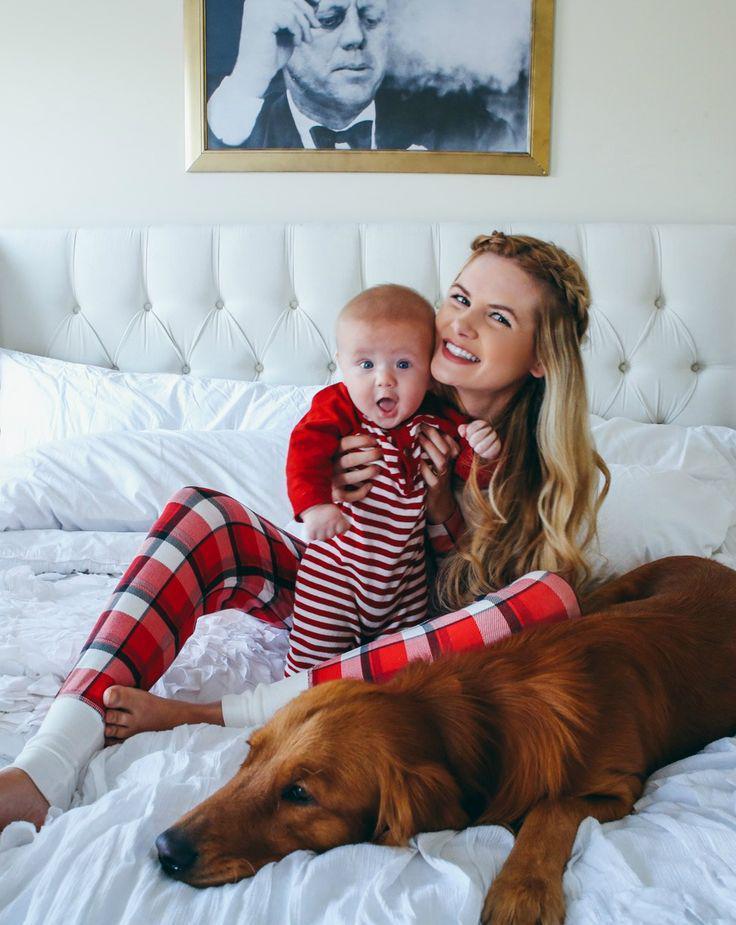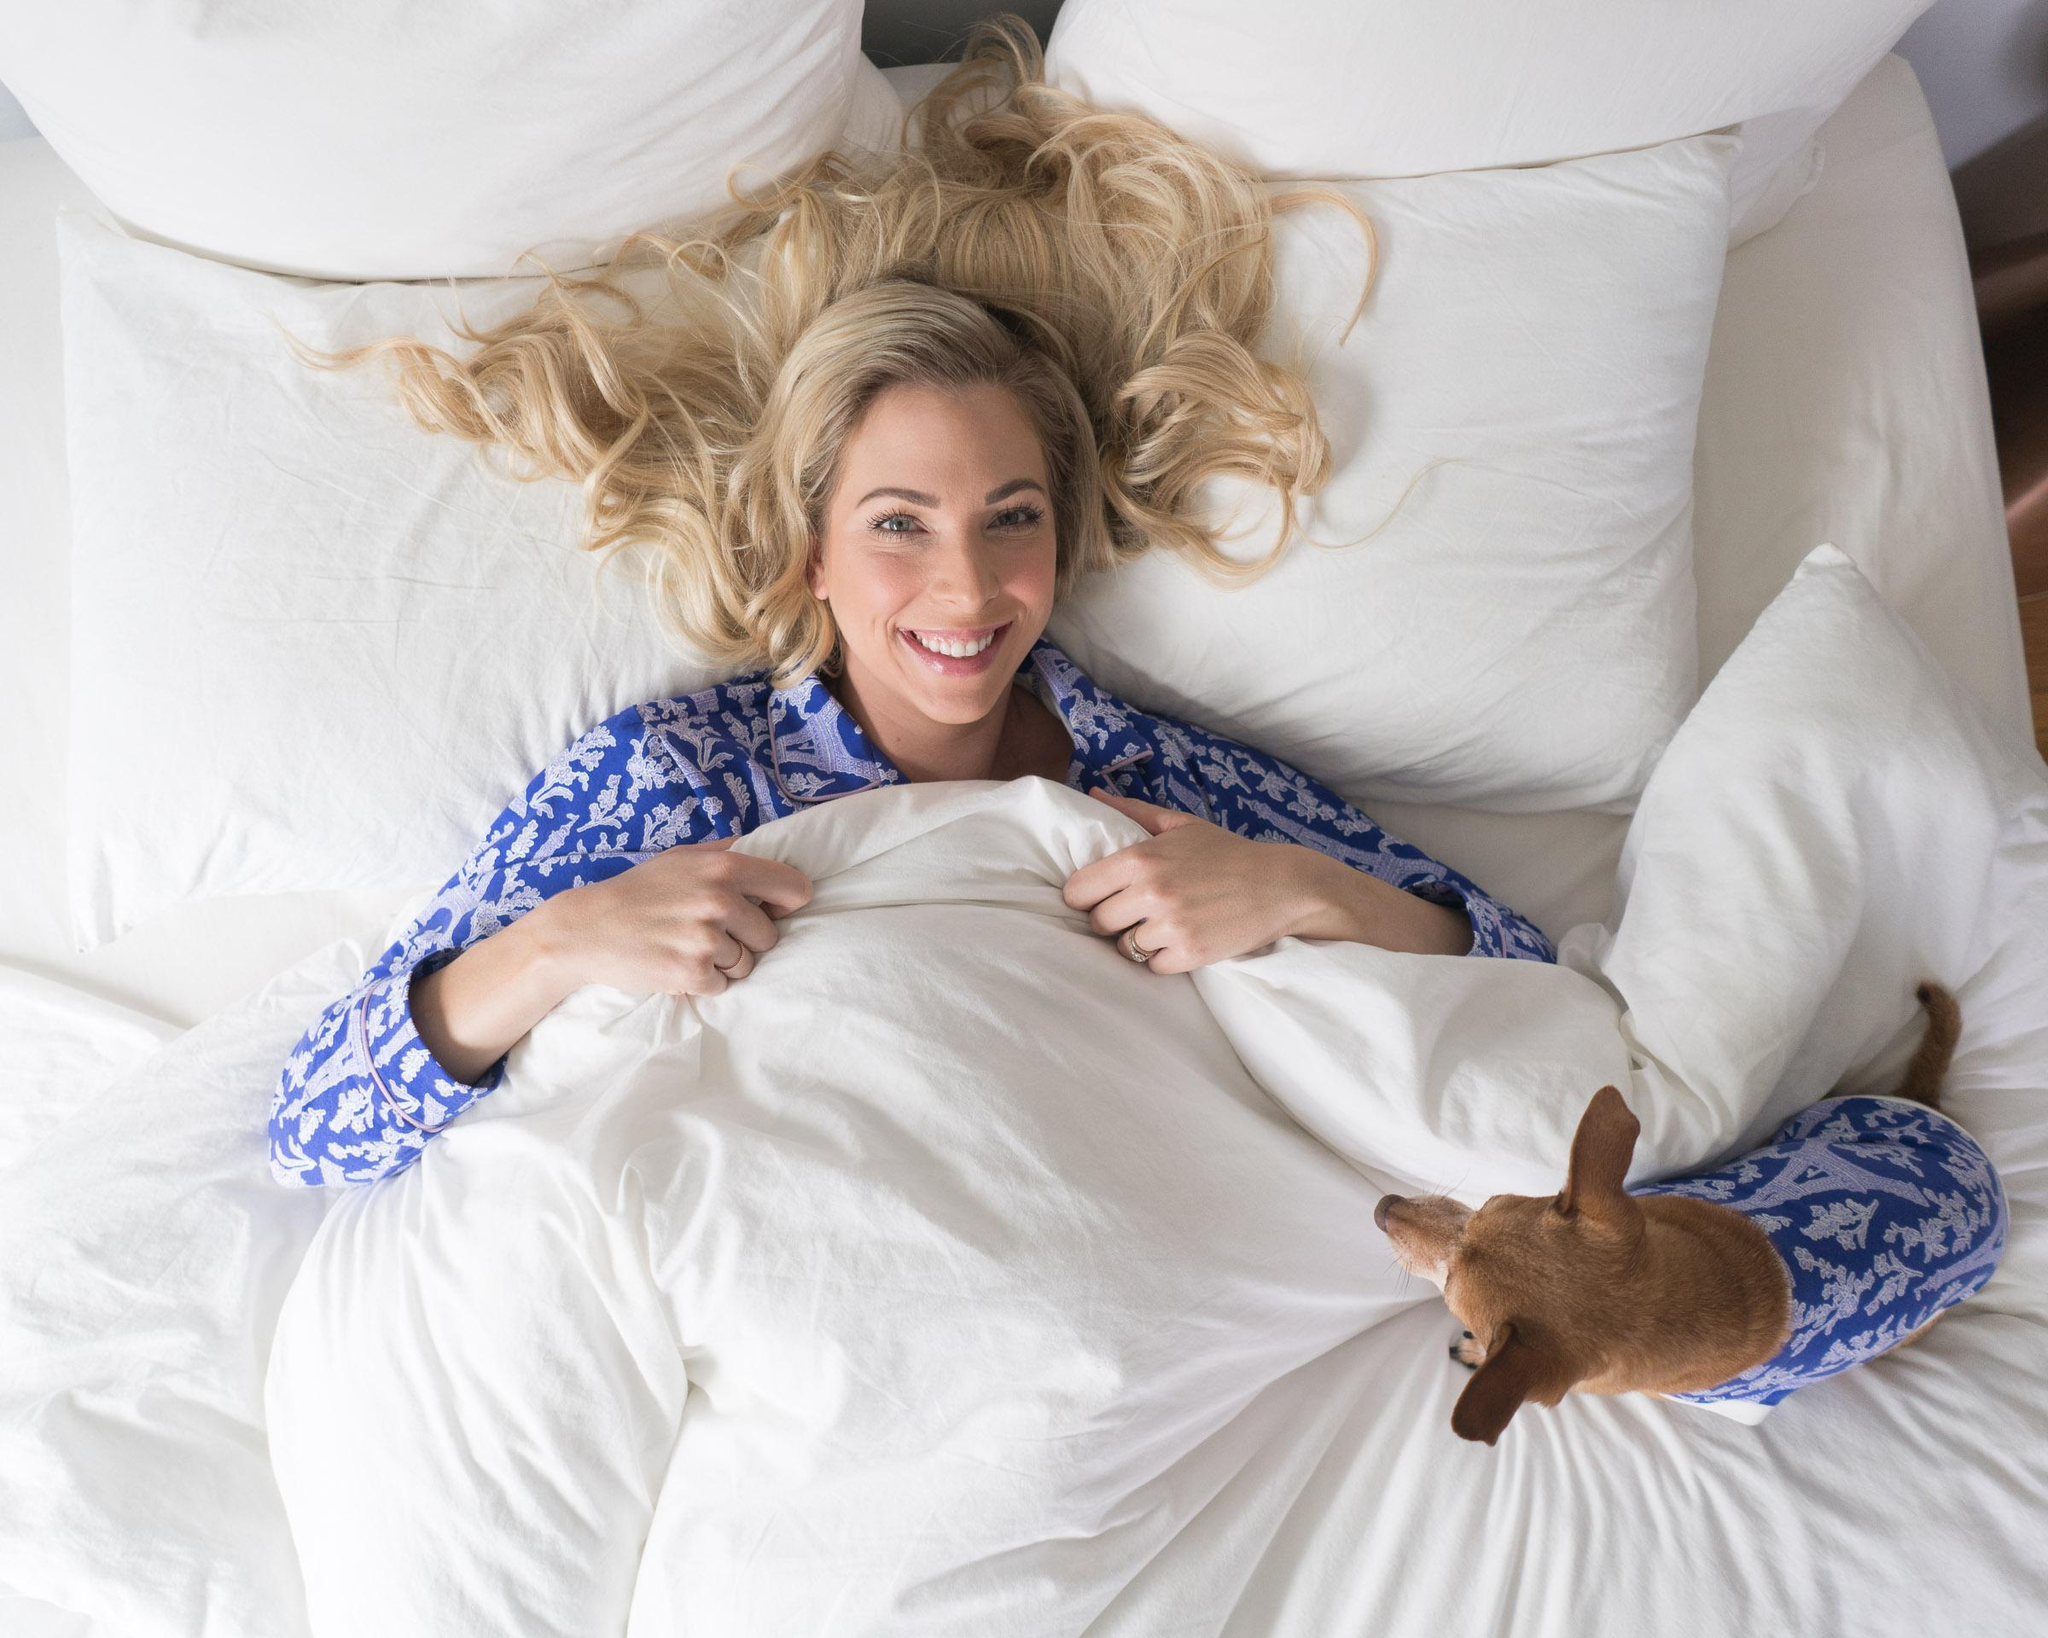The first image is the image on the left, the second image is the image on the right. Examine the images to the left and right. Is the description "An image shows a child in sleepwear near a stuffed animal, with no adult present." accurate? Answer yes or no. No. The first image is the image on the left, the second image is the image on the right. Analyze the images presented: Is the assertion "In one of the pictures, there is a smiling child with a stuffed animal near it, and in the other picture there is a woman alone." valid? Answer yes or no. No. 